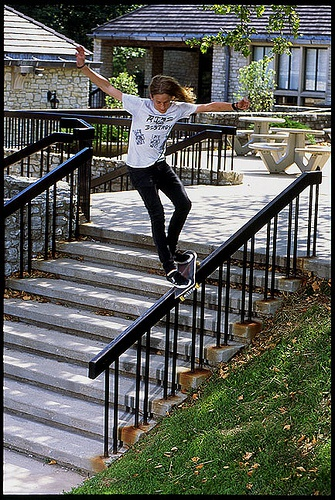Describe the objects in this image and their specific colors. I can see people in black, lavender, and darkgray tones and skateboard in black, white, and gray tones in this image. 